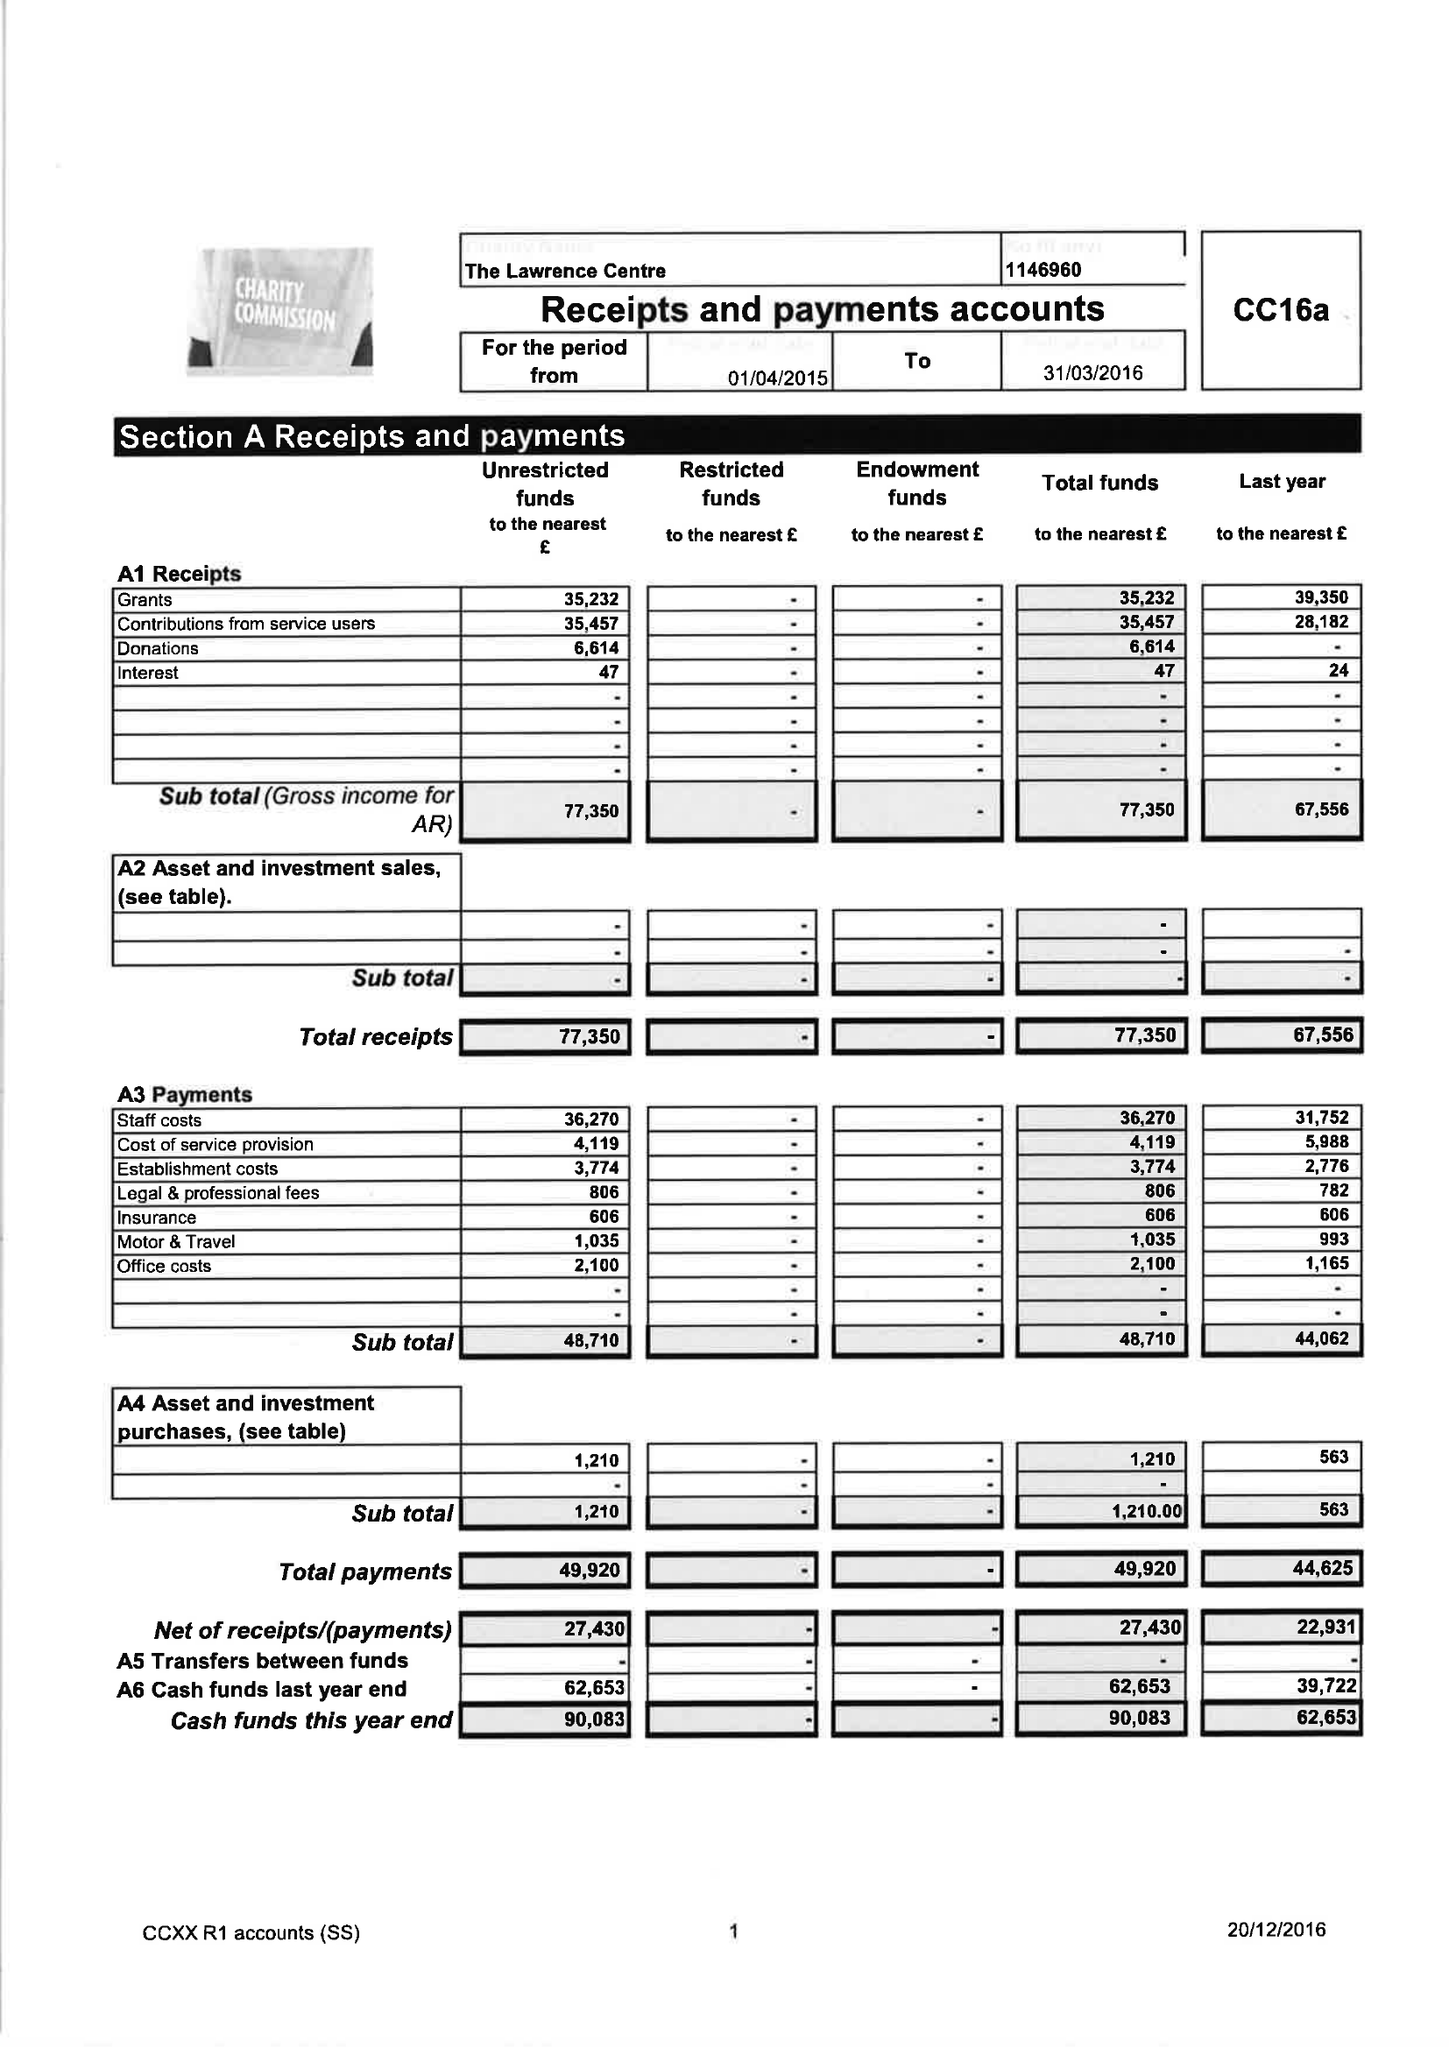What is the value for the address__street_line?
Answer the question using a single word or phrase. 8 CHAMBERLAIN STREET 